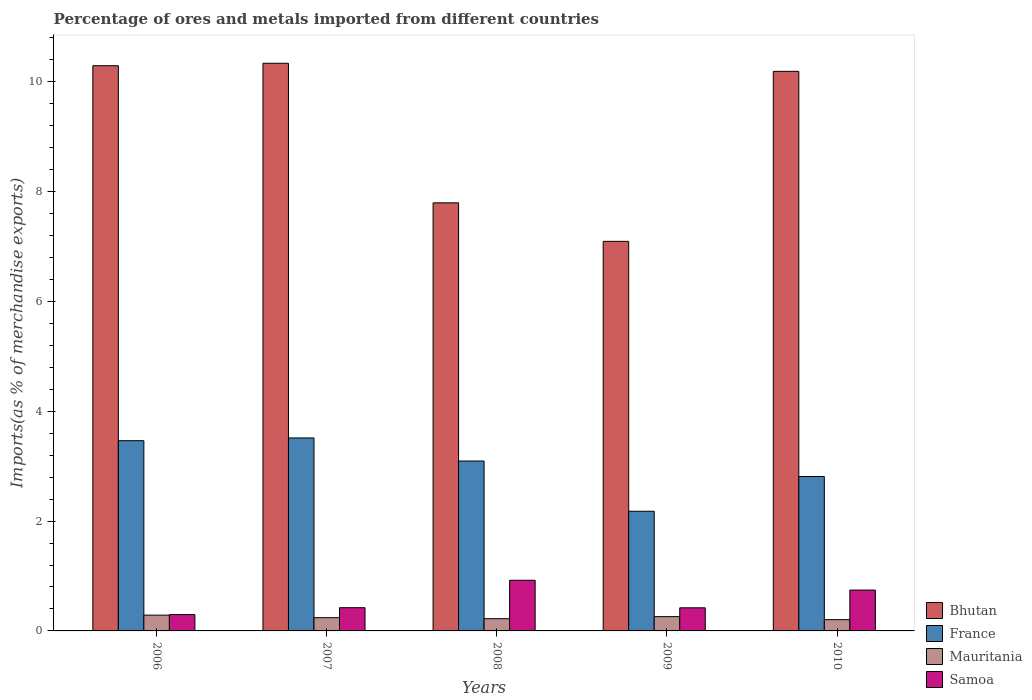How many different coloured bars are there?
Keep it short and to the point. 4. Are the number of bars per tick equal to the number of legend labels?
Keep it short and to the point. Yes. What is the percentage of imports to different countries in Bhutan in 2006?
Make the answer very short. 10.29. Across all years, what is the maximum percentage of imports to different countries in Mauritania?
Your response must be concise. 0.29. Across all years, what is the minimum percentage of imports to different countries in Samoa?
Provide a succinct answer. 0.3. In which year was the percentage of imports to different countries in Mauritania maximum?
Provide a succinct answer. 2006. What is the total percentage of imports to different countries in Mauritania in the graph?
Provide a short and direct response. 1.22. What is the difference between the percentage of imports to different countries in Mauritania in 2006 and that in 2009?
Provide a short and direct response. 0.03. What is the difference between the percentage of imports to different countries in France in 2008 and the percentage of imports to different countries in Mauritania in 2009?
Provide a succinct answer. 2.83. What is the average percentage of imports to different countries in Samoa per year?
Provide a succinct answer. 0.56. In the year 2007, what is the difference between the percentage of imports to different countries in Samoa and percentage of imports to different countries in Mauritania?
Your answer should be very brief. 0.18. In how many years, is the percentage of imports to different countries in Mauritania greater than 8.8 %?
Your answer should be very brief. 0. What is the ratio of the percentage of imports to different countries in Mauritania in 2006 to that in 2007?
Make the answer very short. 1.19. What is the difference between the highest and the second highest percentage of imports to different countries in Bhutan?
Provide a short and direct response. 0.04. What is the difference between the highest and the lowest percentage of imports to different countries in France?
Offer a very short reply. 1.33. In how many years, is the percentage of imports to different countries in Mauritania greater than the average percentage of imports to different countries in Mauritania taken over all years?
Keep it short and to the point. 2. Is it the case that in every year, the sum of the percentage of imports to different countries in Mauritania and percentage of imports to different countries in Samoa is greater than the sum of percentage of imports to different countries in France and percentage of imports to different countries in Bhutan?
Your answer should be compact. Yes. What does the 3rd bar from the left in 2008 represents?
Your answer should be very brief. Mauritania. What does the 2nd bar from the right in 2007 represents?
Ensure brevity in your answer.  Mauritania. Where does the legend appear in the graph?
Give a very brief answer. Bottom right. What is the title of the graph?
Provide a succinct answer. Percentage of ores and metals imported from different countries. Does "Kazakhstan" appear as one of the legend labels in the graph?
Ensure brevity in your answer.  No. What is the label or title of the X-axis?
Your answer should be very brief. Years. What is the label or title of the Y-axis?
Your answer should be very brief. Imports(as % of merchandise exports). What is the Imports(as % of merchandise exports) in Bhutan in 2006?
Provide a succinct answer. 10.29. What is the Imports(as % of merchandise exports) in France in 2006?
Your answer should be very brief. 3.46. What is the Imports(as % of merchandise exports) in Mauritania in 2006?
Keep it short and to the point. 0.29. What is the Imports(as % of merchandise exports) in Samoa in 2006?
Ensure brevity in your answer.  0.3. What is the Imports(as % of merchandise exports) of Bhutan in 2007?
Make the answer very short. 10.33. What is the Imports(as % of merchandise exports) in France in 2007?
Provide a succinct answer. 3.51. What is the Imports(as % of merchandise exports) of Mauritania in 2007?
Give a very brief answer. 0.24. What is the Imports(as % of merchandise exports) in Samoa in 2007?
Make the answer very short. 0.42. What is the Imports(as % of merchandise exports) of Bhutan in 2008?
Provide a succinct answer. 7.79. What is the Imports(as % of merchandise exports) of France in 2008?
Offer a very short reply. 3.09. What is the Imports(as % of merchandise exports) of Mauritania in 2008?
Keep it short and to the point. 0.22. What is the Imports(as % of merchandise exports) in Samoa in 2008?
Your response must be concise. 0.92. What is the Imports(as % of merchandise exports) in Bhutan in 2009?
Keep it short and to the point. 7.09. What is the Imports(as % of merchandise exports) in France in 2009?
Provide a succinct answer. 2.18. What is the Imports(as % of merchandise exports) of Mauritania in 2009?
Your answer should be very brief. 0.26. What is the Imports(as % of merchandise exports) of Samoa in 2009?
Your answer should be very brief. 0.42. What is the Imports(as % of merchandise exports) in Bhutan in 2010?
Ensure brevity in your answer.  10.19. What is the Imports(as % of merchandise exports) of France in 2010?
Offer a terse response. 2.81. What is the Imports(as % of merchandise exports) of Mauritania in 2010?
Your answer should be very brief. 0.21. What is the Imports(as % of merchandise exports) of Samoa in 2010?
Ensure brevity in your answer.  0.74. Across all years, what is the maximum Imports(as % of merchandise exports) of Bhutan?
Ensure brevity in your answer.  10.33. Across all years, what is the maximum Imports(as % of merchandise exports) in France?
Your answer should be very brief. 3.51. Across all years, what is the maximum Imports(as % of merchandise exports) in Mauritania?
Give a very brief answer. 0.29. Across all years, what is the maximum Imports(as % of merchandise exports) in Samoa?
Ensure brevity in your answer.  0.92. Across all years, what is the minimum Imports(as % of merchandise exports) of Bhutan?
Keep it short and to the point. 7.09. Across all years, what is the minimum Imports(as % of merchandise exports) of France?
Offer a terse response. 2.18. Across all years, what is the minimum Imports(as % of merchandise exports) of Mauritania?
Provide a short and direct response. 0.21. Across all years, what is the minimum Imports(as % of merchandise exports) of Samoa?
Keep it short and to the point. 0.3. What is the total Imports(as % of merchandise exports) of Bhutan in the graph?
Ensure brevity in your answer.  45.7. What is the total Imports(as % of merchandise exports) of France in the graph?
Make the answer very short. 15.06. What is the total Imports(as % of merchandise exports) in Mauritania in the graph?
Your answer should be compact. 1.22. What is the total Imports(as % of merchandise exports) of Samoa in the graph?
Give a very brief answer. 2.81. What is the difference between the Imports(as % of merchandise exports) of Bhutan in 2006 and that in 2007?
Make the answer very short. -0.04. What is the difference between the Imports(as % of merchandise exports) of Mauritania in 2006 and that in 2007?
Provide a succinct answer. 0.05. What is the difference between the Imports(as % of merchandise exports) in Samoa in 2006 and that in 2007?
Provide a succinct answer. -0.13. What is the difference between the Imports(as % of merchandise exports) in Bhutan in 2006 and that in 2008?
Offer a terse response. 2.5. What is the difference between the Imports(as % of merchandise exports) in France in 2006 and that in 2008?
Your answer should be very brief. 0.37. What is the difference between the Imports(as % of merchandise exports) of Mauritania in 2006 and that in 2008?
Ensure brevity in your answer.  0.06. What is the difference between the Imports(as % of merchandise exports) in Samoa in 2006 and that in 2008?
Offer a very short reply. -0.62. What is the difference between the Imports(as % of merchandise exports) of Bhutan in 2006 and that in 2009?
Make the answer very short. 3.2. What is the difference between the Imports(as % of merchandise exports) of France in 2006 and that in 2009?
Your answer should be compact. 1.28. What is the difference between the Imports(as % of merchandise exports) in Mauritania in 2006 and that in 2009?
Make the answer very short. 0.03. What is the difference between the Imports(as % of merchandise exports) of Samoa in 2006 and that in 2009?
Provide a short and direct response. -0.12. What is the difference between the Imports(as % of merchandise exports) of Bhutan in 2006 and that in 2010?
Offer a terse response. 0.1. What is the difference between the Imports(as % of merchandise exports) of France in 2006 and that in 2010?
Your answer should be compact. 0.65. What is the difference between the Imports(as % of merchandise exports) in Mauritania in 2006 and that in 2010?
Provide a short and direct response. 0.08. What is the difference between the Imports(as % of merchandise exports) of Samoa in 2006 and that in 2010?
Make the answer very short. -0.45. What is the difference between the Imports(as % of merchandise exports) in Bhutan in 2007 and that in 2008?
Your response must be concise. 2.54. What is the difference between the Imports(as % of merchandise exports) in France in 2007 and that in 2008?
Your answer should be compact. 0.42. What is the difference between the Imports(as % of merchandise exports) of Mauritania in 2007 and that in 2008?
Provide a short and direct response. 0.02. What is the difference between the Imports(as % of merchandise exports) of Samoa in 2007 and that in 2008?
Provide a succinct answer. -0.5. What is the difference between the Imports(as % of merchandise exports) in Bhutan in 2007 and that in 2009?
Your response must be concise. 3.24. What is the difference between the Imports(as % of merchandise exports) in France in 2007 and that in 2009?
Ensure brevity in your answer.  1.33. What is the difference between the Imports(as % of merchandise exports) in Mauritania in 2007 and that in 2009?
Your response must be concise. -0.02. What is the difference between the Imports(as % of merchandise exports) of Samoa in 2007 and that in 2009?
Offer a very short reply. 0. What is the difference between the Imports(as % of merchandise exports) of Bhutan in 2007 and that in 2010?
Keep it short and to the point. 0.15. What is the difference between the Imports(as % of merchandise exports) in France in 2007 and that in 2010?
Keep it short and to the point. 0.7. What is the difference between the Imports(as % of merchandise exports) of Mauritania in 2007 and that in 2010?
Your answer should be compact. 0.04. What is the difference between the Imports(as % of merchandise exports) in Samoa in 2007 and that in 2010?
Your answer should be very brief. -0.32. What is the difference between the Imports(as % of merchandise exports) of Bhutan in 2008 and that in 2009?
Offer a terse response. 0.7. What is the difference between the Imports(as % of merchandise exports) in France in 2008 and that in 2009?
Offer a very short reply. 0.91. What is the difference between the Imports(as % of merchandise exports) in Mauritania in 2008 and that in 2009?
Your answer should be compact. -0.04. What is the difference between the Imports(as % of merchandise exports) of Samoa in 2008 and that in 2009?
Make the answer very short. 0.5. What is the difference between the Imports(as % of merchandise exports) in Bhutan in 2008 and that in 2010?
Keep it short and to the point. -2.39. What is the difference between the Imports(as % of merchandise exports) in France in 2008 and that in 2010?
Provide a succinct answer. 0.28. What is the difference between the Imports(as % of merchandise exports) of Mauritania in 2008 and that in 2010?
Give a very brief answer. 0.02. What is the difference between the Imports(as % of merchandise exports) in Samoa in 2008 and that in 2010?
Make the answer very short. 0.18. What is the difference between the Imports(as % of merchandise exports) of Bhutan in 2009 and that in 2010?
Offer a very short reply. -3.09. What is the difference between the Imports(as % of merchandise exports) of France in 2009 and that in 2010?
Your response must be concise. -0.63. What is the difference between the Imports(as % of merchandise exports) in Mauritania in 2009 and that in 2010?
Provide a succinct answer. 0.06. What is the difference between the Imports(as % of merchandise exports) of Samoa in 2009 and that in 2010?
Your answer should be very brief. -0.32. What is the difference between the Imports(as % of merchandise exports) in Bhutan in 2006 and the Imports(as % of merchandise exports) in France in 2007?
Give a very brief answer. 6.78. What is the difference between the Imports(as % of merchandise exports) of Bhutan in 2006 and the Imports(as % of merchandise exports) of Mauritania in 2007?
Ensure brevity in your answer.  10.05. What is the difference between the Imports(as % of merchandise exports) in Bhutan in 2006 and the Imports(as % of merchandise exports) in Samoa in 2007?
Ensure brevity in your answer.  9.87. What is the difference between the Imports(as % of merchandise exports) of France in 2006 and the Imports(as % of merchandise exports) of Mauritania in 2007?
Offer a terse response. 3.22. What is the difference between the Imports(as % of merchandise exports) in France in 2006 and the Imports(as % of merchandise exports) in Samoa in 2007?
Provide a succinct answer. 3.04. What is the difference between the Imports(as % of merchandise exports) in Mauritania in 2006 and the Imports(as % of merchandise exports) in Samoa in 2007?
Ensure brevity in your answer.  -0.14. What is the difference between the Imports(as % of merchandise exports) in Bhutan in 2006 and the Imports(as % of merchandise exports) in France in 2008?
Your response must be concise. 7.2. What is the difference between the Imports(as % of merchandise exports) in Bhutan in 2006 and the Imports(as % of merchandise exports) in Mauritania in 2008?
Your answer should be compact. 10.07. What is the difference between the Imports(as % of merchandise exports) in Bhutan in 2006 and the Imports(as % of merchandise exports) in Samoa in 2008?
Ensure brevity in your answer.  9.37. What is the difference between the Imports(as % of merchandise exports) in France in 2006 and the Imports(as % of merchandise exports) in Mauritania in 2008?
Keep it short and to the point. 3.24. What is the difference between the Imports(as % of merchandise exports) of France in 2006 and the Imports(as % of merchandise exports) of Samoa in 2008?
Your answer should be very brief. 2.54. What is the difference between the Imports(as % of merchandise exports) in Mauritania in 2006 and the Imports(as % of merchandise exports) in Samoa in 2008?
Keep it short and to the point. -0.63. What is the difference between the Imports(as % of merchandise exports) in Bhutan in 2006 and the Imports(as % of merchandise exports) in France in 2009?
Offer a very short reply. 8.11. What is the difference between the Imports(as % of merchandise exports) in Bhutan in 2006 and the Imports(as % of merchandise exports) in Mauritania in 2009?
Provide a short and direct response. 10.03. What is the difference between the Imports(as % of merchandise exports) of Bhutan in 2006 and the Imports(as % of merchandise exports) of Samoa in 2009?
Provide a succinct answer. 9.87. What is the difference between the Imports(as % of merchandise exports) in France in 2006 and the Imports(as % of merchandise exports) in Mauritania in 2009?
Offer a terse response. 3.2. What is the difference between the Imports(as % of merchandise exports) of France in 2006 and the Imports(as % of merchandise exports) of Samoa in 2009?
Your answer should be compact. 3.04. What is the difference between the Imports(as % of merchandise exports) in Mauritania in 2006 and the Imports(as % of merchandise exports) in Samoa in 2009?
Offer a very short reply. -0.13. What is the difference between the Imports(as % of merchandise exports) of Bhutan in 2006 and the Imports(as % of merchandise exports) of France in 2010?
Keep it short and to the point. 7.48. What is the difference between the Imports(as % of merchandise exports) in Bhutan in 2006 and the Imports(as % of merchandise exports) in Mauritania in 2010?
Your answer should be very brief. 10.08. What is the difference between the Imports(as % of merchandise exports) in Bhutan in 2006 and the Imports(as % of merchandise exports) in Samoa in 2010?
Your answer should be very brief. 9.55. What is the difference between the Imports(as % of merchandise exports) in France in 2006 and the Imports(as % of merchandise exports) in Mauritania in 2010?
Give a very brief answer. 3.26. What is the difference between the Imports(as % of merchandise exports) of France in 2006 and the Imports(as % of merchandise exports) of Samoa in 2010?
Ensure brevity in your answer.  2.72. What is the difference between the Imports(as % of merchandise exports) of Mauritania in 2006 and the Imports(as % of merchandise exports) of Samoa in 2010?
Offer a terse response. -0.46. What is the difference between the Imports(as % of merchandise exports) in Bhutan in 2007 and the Imports(as % of merchandise exports) in France in 2008?
Ensure brevity in your answer.  7.24. What is the difference between the Imports(as % of merchandise exports) in Bhutan in 2007 and the Imports(as % of merchandise exports) in Mauritania in 2008?
Give a very brief answer. 10.11. What is the difference between the Imports(as % of merchandise exports) of Bhutan in 2007 and the Imports(as % of merchandise exports) of Samoa in 2008?
Offer a terse response. 9.41. What is the difference between the Imports(as % of merchandise exports) of France in 2007 and the Imports(as % of merchandise exports) of Mauritania in 2008?
Offer a very short reply. 3.29. What is the difference between the Imports(as % of merchandise exports) of France in 2007 and the Imports(as % of merchandise exports) of Samoa in 2008?
Give a very brief answer. 2.59. What is the difference between the Imports(as % of merchandise exports) of Mauritania in 2007 and the Imports(as % of merchandise exports) of Samoa in 2008?
Ensure brevity in your answer.  -0.68. What is the difference between the Imports(as % of merchandise exports) in Bhutan in 2007 and the Imports(as % of merchandise exports) in France in 2009?
Keep it short and to the point. 8.16. What is the difference between the Imports(as % of merchandise exports) in Bhutan in 2007 and the Imports(as % of merchandise exports) in Mauritania in 2009?
Give a very brief answer. 10.07. What is the difference between the Imports(as % of merchandise exports) of Bhutan in 2007 and the Imports(as % of merchandise exports) of Samoa in 2009?
Keep it short and to the point. 9.91. What is the difference between the Imports(as % of merchandise exports) of France in 2007 and the Imports(as % of merchandise exports) of Mauritania in 2009?
Provide a succinct answer. 3.25. What is the difference between the Imports(as % of merchandise exports) of France in 2007 and the Imports(as % of merchandise exports) of Samoa in 2009?
Offer a terse response. 3.09. What is the difference between the Imports(as % of merchandise exports) of Mauritania in 2007 and the Imports(as % of merchandise exports) of Samoa in 2009?
Give a very brief answer. -0.18. What is the difference between the Imports(as % of merchandise exports) of Bhutan in 2007 and the Imports(as % of merchandise exports) of France in 2010?
Provide a succinct answer. 7.52. What is the difference between the Imports(as % of merchandise exports) in Bhutan in 2007 and the Imports(as % of merchandise exports) in Mauritania in 2010?
Give a very brief answer. 10.13. What is the difference between the Imports(as % of merchandise exports) of Bhutan in 2007 and the Imports(as % of merchandise exports) of Samoa in 2010?
Keep it short and to the point. 9.59. What is the difference between the Imports(as % of merchandise exports) of France in 2007 and the Imports(as % of merchandise exports) of Mauritania in 2010?
Your answer should be very brief. 3.31. What is the difference between the Imports(as % of merchandise exports) of France in 2007 and the Imports(as % of merchandise exports) of Samoa in 2010?
Make the answer very short. 2.77. What is the difference between the Imports(as % of merchandise exports) in Mauritania in 2007 and the Imports(as % of merchandise exports) in Samoa in 2010?
Your response must be concise. -0.5. What is the difference between the Imports(as % of merchandise exports) in Bhutan in 2008 and the Imports(as % of merchandise exports) in France in 2009?
Your answer should be very brief. 5.62. What is the difference between the Imports(as % of merchandise exports) in Bhutan in 2008 and the Imports(as % of merchandise exports) in Mauritania in 2009?
Make the answer very short. 7.53. What is the difference between the Imports(as % of merchandise exports) in Bhutan in 2008 and the Imports(as % of merchandise exports) in Samoa in 2009?
Provide a short and direct response. 7.37. What is the difference between the Imports(as % of merchandise exports) in France in 2008 and the Imports(as % of merchandise exports) in Mauritania in 2009?
Offer a terse response. 2.83. What is the difference between the Imports(as % of merchandise exports) in France in 2008 and the Imports(as % of merchandise exports) in Samoa in 2009?
Provide a succinct answer. 2.67. What is the difference between the Imports(as % of merchandise exports) of Mauritania in 2008 and the Imports(as % of merchandise exports) of Samoa in 2009?
Provide a succinct answer. -0.2. What is the difference between the Imports(as % of merchandise exports) of Bhutan in 2008 and the Imports(as % of merchandise exports) of France in 2010?
Your answer should be very brief. 4.98. What is the difference between the Imports(as % of merchandise exports) of Bhutan in 2008 and the Imports(as % of merchandise exports) of Mauritania in 2010?
Make the answer very short. 7.59. What is the difference between the Imports(as % of merchandise exports) in Bhutan in 2008 and the Imports(as % of merchandise exports) in Samoa in 2010?
Provide a succinct answer. 7.05. What is the difference between the Imports(as % of merchandise exports) of France in 2008 and the Imports(as % of merchandise exports) of Mauritania in 2010?
Keep it short and to the point. 2.89. What is the difference between the Imports(as % of merchandise exports) of France in 2008 and the Imports(as % of merchandise exports) of Samoa in 2010?
Offer a very short reply. 2.35. What is the difference between the Imports(as % of merchandise exports) of Mauritania in 2008 and the Imports(as % of merchandise exports) of Samoa in 2010?
Keep it short and to the point. -0.52. What is the difference between the Imports(as % of merchandise exports) of Bhutan in 2009 and the Imports(as % of merchandise exports) of France in 2010?
Your response must be concise. 4.28. What is the difference between the Imports(as % of merchandise exports) of Bhutan in 2009 and the Imports(as % of merchandise exports) of Mauritania in 2010?
Offer a terse response. 6.89. What is the difference between the Imports(as % of merchandise exports) in Bhutan in 2009 and the Imports(as % of merchandise exports) in Samoa in 2010?
Offer a very short reply. 6.35. What is the difference between the Imports(as % of merchandise exports) in France in 2009 and the Imports(as % of merchandise exports) in Mauritania in 2010?
Give a very brief answer. 1.97. What is the difference between the Imports(as % of merchandise exports) in France in 2009 and the Imports(as % of merchandise exports) in Samoa in 2010?
Offer a very short reply. 1.43. What is the difference between the Imports(as % of merchandise exports) of Mauritania in 2009 and the Imports(as % of merchandise exports) of Samoa in 2010?
Give a very brief answer. -0.48. What is the average Imports(as % of merchandise exports) of Bhutan per year?
Keep it short and to the point. 9.14. What is the average Imports(as % of merchandise exports) of France per year?
Provide a succinct answer. 3.01. What is the average Imports(as % of merchandise exports) of Mauritania per year?
Give a very brief answer. 0.24. What is the average Imports(as % of merchandise exports) of Samoa per year?
Give a very brief answer. 0.56. In the year 2006, what is the difference between the Imports(as % of merchandise exports) in Bhutan and Imports(as % of merchandise exports) in France?
Make the answer very short. 6.83. In the year 2006, what is the difference between the Imports(as % of merchandise exports) in Bhutan and Imports(as % of merchandise exports) in Mauritania?
Provide a succinct answer. 10. In the year 2006, what is the difference between the Imports(as % of merchandise exports) of Bhutan and Imports(as % of merchandise exports) of Samoa?
Your answer should be compact. 9.99. In the year 2006, what is the difference between the Imports(as % of merchandise exports) of France and Imports(as % of merchandise exports) of Mauritania?
Offer a terse response. 3.18. In the year 2006, what is the difference between the Imports(as % of merchandise exports) of France and Imports(as % of merchandise exports) of Samoa?
Offer a very short reply. 3.17. In the year 2006, what is the difference between the Imports(as % of merchandise exports) in Mauritania and Imports(as % of merchandise exports) in Samoa?
Your response must be concise. -0.01. In the year 2007, what is the difference between the Imports(as % of merchandise exports) in Bhutan and Imports(as % of merchandise exports) in France?
Make the answer very short. 6.82. In the year 2007, what is the difference between the Imports(as % of merchandise exports) of Bhutan and Imports(as % of merchandise exports) of Mauritania?
Offer a terse response. 10.09. In the year 2007, what is the difference between the Imports(as % of merchandise exports) in Bhutan and Imports(as % of merchandise exports) in Samoa?
Provide a short and direct response. 9.91. In the year 2007, what is the difference between the Imports(as % of merchandise exports) of France and Imports(as % of merchandise exports) of Mauritania?
Provide a succinct answer. 3.27. In the year 2007, what is the difference between the Imports(as % of merchandise exports) of France and Imports(as % of merchandise exports) of Samoa?
Offer a very short reply. 3.09. In the year 2007, what is the difference between the Imports(as % of merchandise exports) of Mauritania and Imports(as % of merchandise exports) of Samoa?
Provide a short and direct response. -0.18. In the year 2008, what is the difference between the Imports(as % of merchandise exports) in Bhutan and Imports(as % of merchandise exports) in France?
Give a very brief answer. 4.7. In the year 2008, what is the difference between the Imports(as % of merchandise exports) of Bhutan and Imports(as % of merchandise exports) of Mauritania?
Ensure brevity in your answer.  7.57. In the year 2008, what is the difference between the Imports(as % of merchandise exports) in Bhutan and Imports(as % of merchandise exports) in Samoa?
Offer a very short reply. 6.87. In the year 2008, what is the difference between the Imports(as % of merchandise exports) of France and Imports(as % of merchandise exports) of Mauritania?
Provide a succinct answer. 2.87. In the year 2008, what is the difference between the Imports(as % of merchandise exports) in France and Imports(as % of merchandise exports) in Samoa?
Your answer should be very brief. 2.17. In the year 2008, what is the difference between the Imports(as % of merchandise exports) of Mauritania and Imports(as % of merchandise exports) of Samoa?
Offer a very short reply. -0.7. In the year 2009, what is the difference between the Imports(as % of merchandise exports) of Bhutan and Imports(as % of merchandise exports) of France?
Your answer should be compact. 4.91. In the year 2009, what is the difference between the Imports(as % of merchandise exports) of Bhutan and Imports(as % of merchandise exports) of Mauritania?
Offer a terse response. 6.83. In the year 2009, what is the difference between the Imports(as % of merchandise exports) of Bhutan and Imports(as % of merchandise exports) of Samoa?
Keep it short and to the point. 6.67. In the year 2009, what is the difference between the Imports(as % of merchandise exports) of France and Imports(as % of merchandise exports) of Mauritania?
Ensure brevity in your answer.  1.92. In the year 2009, what is the difference between the Imports(as % of merchandise exports) of France and Imports(as % of merchandise exports) of Samoa?
Your response must be concise. 1.76. In the year 2009, what is the difference between the Imports(as % of merchandise exports) in Mauritania and Imports(as % of merchandise exports) in Samoa?
Provide a succinct answer. -0.16. In the year 2010, what is the difference between the Imports(as % of merchandise exports) of Bhutan and Imports(as % of merchandise exports) of France?
Offer a terse response. 7.38. In the year 2010, what is the difference between the Imports(as % of merchandise exports) of Bhutan and Imports(as % of merchandise exports) of Mauritania?
Your answer should be very brief. 9.98. In the year 2010, what is the difference between the Imports(as % of merchandise exports) of Bhutan and Imports(as % of merchandise exports) of Samoa?
Your response must be concise. 9.44. In the year 2010, what is the difference between the Imports(as % of merchandise exports) of France and Imports(as % of merchandise exports) of Mauritania?
Make the answer very short. 2.61. In the year 2010, what is the difference between the Imports(as % of merchandise exports) in France and Imports(as % of merchandise exports) in Samoa?
Make the answer very short. 2.07. In the year 2010, what is the difference between the Imports(as % of merchandise exports) in Mauritania and Imports(as % of merchandise exports) in Samoa?
Offer a very short reply. -0.54. What is the ratio of the Imports(as % of merchandise exports) of France in 2006 to that in 2007?
Ensure brevity in your answer.  0.99. What is the ratio of the Imports(as % of merchandise exports) of Mauritania in 2006 to that in 2007?
Make the answer very short. 1.19. What is the ratio of the Imports(as % of merchandise exports) of Samoa in 2006 to that in 2007?
Offer a very short reply. 0.7. What is the ratio of the Imports(as % of merchandise exports) of Bhutan in 2006 to that in 2008?
Make the answer very short. 1.32. What is the ratio of the Imports(as % of merchandise exports) of France in 2006 to that in 2008?
Your answer should be very brief. 1.12. What is the ratio of the Imports(as % of merchandise exports) of Mauritania in 2006 to that in 2008?
Offer a terse response. 1.29. What is the ratio of the Imports(as % of merchandise exports) in Samoa in 2006 to that in 2008?
Offer a very short reply. 0.32. What is the ratio of the Imports(as % of merchandise exports) in Bhutan in 2006 to that in 2009?
Ensure brevity in your answer.  1.45. What is the ratio of the Imports(as % of merchandise exports) of France in 2006 to that in 2009?
Your answer should be very brief. 1.59. What is the ratio of the Imports(as % of merchandise exports) in Mauritania in 2006 to that in 2009?
Give a very brief answer. 1.11. What is the ratio of the Imports(as % of merchandise exports) in Samoa in 2006 to that in 2009?
Give a very brief answer. 0.71. What is the ratio of the Imports(as % of merchandise exports) in Bhutan in 2006 to that in 2010?
Keep it short and to the point. 1.01. What is the ratio of the Imports(as % of merchandise exports) of France in 2006 to that in 2010?
Your answer should be compact. 1.23. What is the ratio of the Imports(as % of merchandise exports) in Mauritania in 2006 to that in 2010?
Your answer should be very brief. 1.4. What is the ratio of the Imports(as % of merchandise exports) in Samoa in 2006 to that in 2010?
Ensure brevity in your answer.  0.4. What is the ratio of the Imports(as % of merchandise exports) in Bhutan in 2007 to that in 2008?
Your answer should be very brief. 1.33. What is the ratio of the Imports(as % of merchandise exports) in France in 2007 to that in 2008?
Your answer should be very brief. 1.14. What is the ratio of the Imports(as % of merchandise exports) in Mauritania in 2007 to that in 2008?
Offer a terse response. 1.08. What is the ratio of the Imports(as % of merchandise exports) in Samoa in 2007 to that in 2008?
Provide a short and direct response. 0.46. What is the ratio of the Imports(as % of merchandise exports) in Bhutan in 2007 to that in 2009?
Ensure brevity in your answer.  1.46. What is the ratio of the Imports(as % of merchandise exports) of France in 2007 to that in 2009?
Your answer should be very brief. 1.61. What is the ratio of the Imports(as % of merchandise exports) of Mauritania in 2007 to that in 2009?
Provide a short and direct response. 0.93. What is the ratio of the Imports(as % of merchandise exports) in Samoa in 2007 to that in 2009?
Make the answer very short. 1. What is the ratio of the Imports(as % of merchandise exports) of Bhutan in 2007 to that in 2010?
Provide a short and direct response. 1.01. What is the ratio of the Imports(as % of merchandise exports) of France in 2007 to that in 2010?
Offer a terse response. 1.25. What is the ratio of the Imports(as % of merchandise exports) of Mauritania in 2007 to that in 2010?
Give a very brief answer. 1.18. What is the ratio of the Imports(as % of merchandise exports) of Samoa in 2007 to that in 2010?
Your answer should be compact. 0.57. What is the ratio of the Imports(as % of merchandise exports) of Bhutan in 2008 to that in 2009?
Your response must be concise. 1.1. What is the ratio of the Imports(as % of merchandise exports) of France in 2008 to that in 2009?
Offer a terse response. 1.42. What is the ratio of the Imports(as % of merchandise exports) of Mauritania in 2008 to that in 2009?
Your answer should be very brief. 0.86. What is the ratio of the Imports(as % of merchandise exports) in Samoa in 2008 to that in 2009?
Your answer should be compact. 2.19. What is the ratio of the Imports(as % of merchandise exports) in Bhutan in 2008 to that in 2010?
Make the answer very short. 0.77. What is the ratio of the Imports(as % of merchandise exports) of France in 2008 to that in 2010?
Keep it short and to the point. 1.1. What is the ratio of the Imports(as % of merchandise exports) in Mauritania in 2008 to that in 2010?
Provide a short and direct response. 1.09. What is the ratio of the Imports(as % of merchandise exports) in Samoa in 2008 to that in 2010?
Offer a very short reply. 1.24. What is the ratio of the Imports(as % of merchandise exports) of Bhutan in 2009 to that in 2010?
Give a very brief answer. 0.7. What is the ratio of the Imports(as % of merchandise exports) in France in 2009 to that in 2010?
Your answer should be very brief. 0.78. What is the ratio of the Imports(as % of merchandise exports) in Mauritania in 2009 to that in 2010?
Your answer should be very brief. 1.27. What is the ratio of the Imports(as % of merchandise exports) of Samoa in 2009 to that in 2010?
Provide a succinct answer. 0.57. What is the difference between the highest and the second highest Imports(as % of merchandise exports) of Bhutan?
Give a very brief answer. 0.04. What is the difference between the highest and the second highest Imports(as % of merchandise exports) of France?
Your answer should be very brief. 0.05. What is the difference between the highest and the second highest Imports(as % of merchandise exports) of Mauritania?
Ensure brevity in your answer.  0.03. What is the difference between the highest and the second highest Imports(as % of merchandise exports) in Samoa?
Offer a very short reply. 0.18. What is the difference between the highest and the lowest Imports(as % of merchandise exports) in Bhutan?
Offer a terse response. 3.24. What is the difference between the highest and the lowest Imports(as % of merchandise exports) of France?
Your response must be concise. 1.33. What is the difference between the highest and the lowest Imports(as % of merchandise exports) in Mauritania?
Offer a very short reply. 0.08. What is the difference between the highest and the lowest Imports(as % of merchandise exports) in Samoa?
Your answer should be very brief. 0.62. 